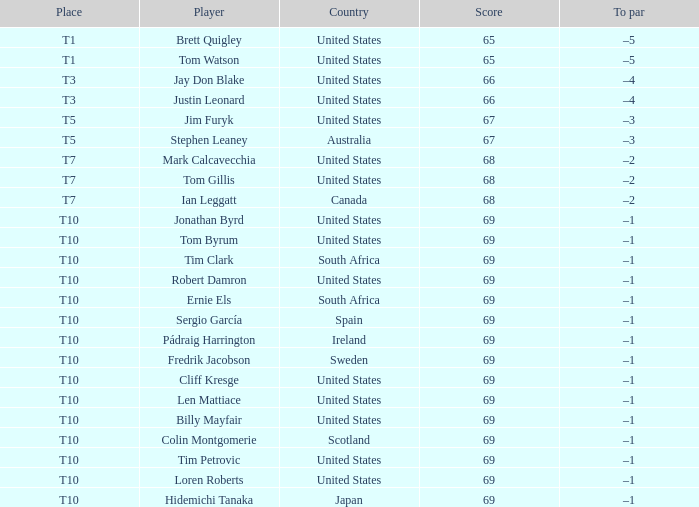Can you identify the player known as t3? Jay Don Blake, Justin Leonard. 